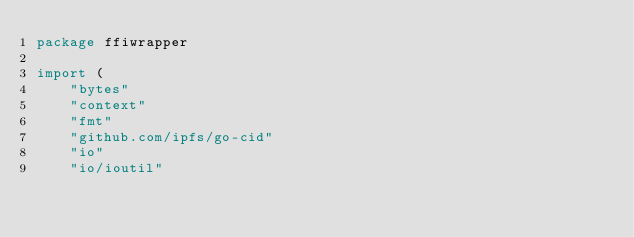Convert code to text. <code><loc_0><loc_0><loc_500><loc_500><_Go_>package ffiwrapper

import (
	"bytes"
	"context"
	"fmt"
	"github.com/ipfs/go-cid"
	"io"
	"io/ioutil"</code> 